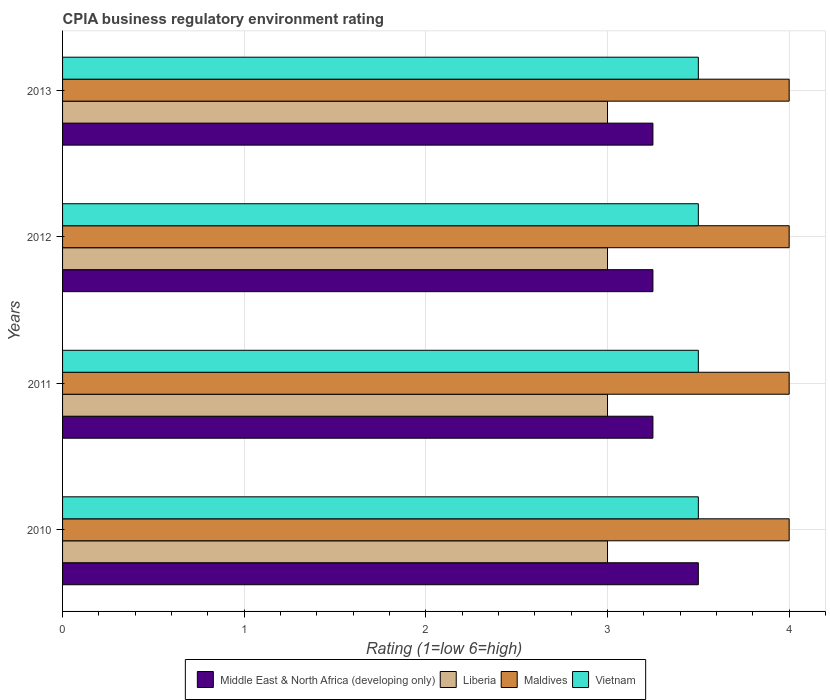How many different coloured bars are there?
Give a very brief answer. 4. Are the number of bars per tick equal to the number of legend labels?
Offer a very short reply. Yes. What is the label of the 4th group of bars from the top?
Offer a very short reply. 2010. What is the CPIA rating in Middle East & North Africa (developing only) in 2010?
Keep it short and to the point. 3.5. Across all years, what is the maximum CPIA rating in Maldives?
Provide a short and direct response. 4. In which year was the CPIA rating in Liberia maximum?
Offer a terse response. 2010. What is the average CPIA rating in Middle East & North Africa (developing only) per year?
Provide a succinct answer. 3.31. Is it the case that in every year, the sum of the CPIA rating in Middle East & North Africa (developing only) and CPIA rating in Liberia is greater than the sum of CPIA rating in Vietnam and CPIA rating in Maldives?
Give a very brief answer. No. What does the 3rd bar from the top in 2013 represents?
Offer a terse response. Liberia. What does the 2nd bar from the bottom in 2012 represents?
Ensure brevity in your answer.  Liberia. How many bars are there?
Make the answer very short. 16. Are all the bars in the graph horizontal?
Make the answer very short. Yes. How many years are there in the graph?
Your answer should be very brief. 4. What is the difference between two consecutive major ticks on the X-axis?
Your answer should be very brief. 1. Does the graph contain grids?
Offer a very short reply. Yes. Where does the legend appear in the graph?
Your response must be concise. Bottom center. What is the title of the graph?
Keep it short and to the point. CPIA business regulatory environment rating. What is the label or title of the X-axis?
Your answer should be compact. Rating (1=low 6=high). What is the label or title of the Y-axis?
Provide a succinct answer. Years. What is the Rating (1=low 6=high) in Middle East & North Africa (developing only) in 2010?
Keep it short and to the point. 3.5. What is the Rating (1=low 6=high) of Maldives in 2010?
Your answer should be compact. 4. What is the Rating (1=low 6=high) in Vietnam in 2010?
Your answer should be very brief. 3.5. What is the Rating (1=low 6=high) of Liberia in 2011?
Keep it short and to the point. 3. What is the Rating (1=low 6=high) in Maldives in 2012?
Ensure brevity in your answer.  4. What is the Rating (1=low 6=high) in Vietnam in 2012?
Provide a succinct answer. 3.5. What is the Rating (1=low 6=high) of Middle East & North Africa (developing only) in 2013?
Keep it short and to the point. 3.25. What is the Rating (1=low 6=high) of Vietnam in 2013?
Your answer should be compact. 3.5. Across all years, what is the maximum Rating (1=low 6=high) in Middle East & North Africa (developing only)?
Make the answer very short. 3.5. Across all years, what is the maximum Rating (1=low 6=high) in Maldives?
Give a very brief answer. 4. Across all years, what is the maximum Rating (1=low 6=high) of Vietnam?
Provide a short and direct response. 3.5. Across all years, what is the minimum Rating (1=low 6=high) in Middle East & North Africa (developing only)?
Your answer should be very brief. 3.25. Across all years, what is the minimum Rating (1=low 6=high) of Liberia?
Offer a very short reply. 3. Across all years, what is the minimum Rating (1=low 6=high) in Vietnam?
Your response must be concise. 3.5. What is the total Rating (1=low 6=high) of Middle East & North Africa (developing only) in the graph?
Your answer should be compact. 13.25. What is the total Rating (1=low 6=high) of Liberia in the graph?
Ensure brevity in your answer.  12. What is the total Rating (1=low 6=high) of Maldives in the graph?
Provide a short and direct response. 16. What is the total Rating (1=low 6=high) in Vietnam in the graph?
Your answer should be very brief. 14. What is the difference between the Rating (1=low 6=high) in Middle East & North Africa (developing only) in 2010 and that in 2011?
Your answer should be compact. 0.25. What is the difference between the Rating (1=low 6=high) of Liberia in 2010 and that in 2011?
Provide a succinct answer. 0. What is the difference between the Rating (1=low 6=high) in Vietnam in 2010 and that in 2011?
Give a very brief answer. 0. What is the difference between the Rating (1=low 6=high) of Maldives in 2010 and that in 2012?
Keep it short and to the point. 0. What is the difference between the Rating (1=low 6=high) in Middle East & North Africa (developing only) in 2010 and that in 2013?
Ensure brevity in your answer.  0.25. What is the difference between the Rating (1=low 6=high) of Liberia in 2010 and that in 2013?
Offer a terse response. 0. What is the difference between the Rating (1=low 6=high) in Maldives in 2010 and that in 2013?
Provide a short and direct response. 0. What is the difference between the Rating (1=low 6=high) of Vietnam in 2010 and that in 2013?
Offer a terse response. 0. What is the difference between the Rating (1=low 6=high) in Middle East & North Africa (developing only) in 2011 and that in 2012?
Your answer should be compact. 0. What is the difference between the Rating (1=low 6=high) of Liberia in 2011 and that in 2012?
Your answer should be compact. 0. What is the difference between the Rating (1=low 6=high) in Maldives in 2011 and that in 2012?
Your response must be concise. 0. What is the difference between the Rating (1=low 6=high) in Vietnam in 2011 and that in 2012?
Make the answer very short. 0. What is the difference between the Rating (1=low 6=high) in Middle East & North Africa (developing only) in 2011 and that in 2013?
Your answer should be very brief. 0. What is the difference between the Rating (1=low 6=high) of Maldives in 2011 and that in 2013?
Offer a very short reply. 0. What is the difference between the Rating (1=low 6=high) of Liberia in 2012 and that in 2013?
Ensure brevity in your answer.  0. What is the difference between the Rating (1=low 6=high) of Maldives in 2012 and that in 2013?
Give a very brief answer. 0. What is the difference between the Rating (1=low 6=high) in Middle East & North Africa (developing only) in 2010 and the Rating (1=low 6=high) in Vietnam in 2011?
Provide a short and direct response. 0. What is the difference between the Rating (1=low 6=high) in Maldives in 2010 and the Rating (1=low 6=high) in Vietnam in 2011?
Offer a very short reply. 0.5. What is the difference between the Rating (1=low 6=high) in Middle East & North Africa (developing only) in 2010 and the Rating (1=low 6=high) in Maldives in 2012?
Your response must be concise. -0.5. What is the difference between the Rating (1=low 6=high) in Middle East & North Africa (developing only) in 2010 and the Rating (1=low 6=high) in Vietnam in 2012?
Give a very brief answer. 0. What is the difference between the Rating (1=low 6=high) in Maldives in 2010 and the Rating (1=low 6=high) in Vietnam in 2012?
Give a very brief answer. 0.5. What is the difference between the Rating (1=low 6=high) of Middle East & North Africa (developing only) in 2010 and the Rating (1=low 6=high) of Maldives in 2013?
Your response must be concise. -0.5. What is the difference between the Rating (1=low 6=high) in Middle East & North Africa (developing only) in 2011 and the Rating (1=low 6=high) in Maldives in 2012?
Your response must be concise. -0.75. What is the difference between the Rating (1=low 6=high) of Middle East & North Africa (developing only) in 2011 and the Rating (1=low 6=high) of Vietnam in 2012?
Your response must be concise. -0.25. What is the difference between the Rating (1=low 6=high) of Maldives in 2011 and the Rating (1=low 6=high) of Vietnam in 2012?
Your response must be concise. 0.5. What is the difference between the Rating (1=low 6=high) of Middle East & North Africa (developing only) in 2011 and the Rating (1=low 6=high) of Maldives in 2013?
Provide a succinct answer. -0.75. What is the difference between the Rating (1=low 6=high) of Middle East & North Africa (developing only) in 2011 and the Rating (1=low 6=high) of Vietnam in 2013?
Provide a succinct answer. -0.25. What is the difference between the Rating (1=low 6=high) of Liberia in 2011 and the Rating (1=low 6=high) of Maldives in 2013?
Ensure brevity in your answer.  -1. What is the difference between the Rating (1=low 6=high) in Middle East & North Africa (developing only) in 2012 and the Rating (1=low 6=high) in Maldives in 2013?
Give a very brief answer. -0.75. What is the difference between the Rating (1=low 6=high) in Maldives in 2012 and the Rating (1=low 6=high) in Vietnam in 2013?
Offer a terse response. 0.5. What is the average Rating (1=low 6=high) in Middle East & North Africa (developing only) per year?
Provide a short and direct response. 3.31. What is the average Rating (1=low 6=high) in Liberia per year?
Your answer should be compact. 3. What is the average Rating (1=low 6=high) of Maldives per year?
Your response must be concise. 4. What is the average Rating (1=low 6=high) of Vietnam per year?
Offer a very short reply. 3.5. In the year 2010, what is the difference between the Rating (1=low 6=high) of Liberia and Rating (1=low 6=high) of Maldives?
Your response must be concise. -1. In the year 2011, what is the difference between the Rating (1=low 6=high) of Middle East & North Africa (developing only) and Rating (1=low 6=high) of Maldives?
Your response must be concise. -0.75. In the year 2011, what is the difference between the Rating (1=low 6=high) of Liberia and Rating (1=low 6=high) of Maldives?
Keep it short and to the point. -1. In the year 2012, what is the difference between the Rating (1=low 6=high) of Middle East & North Africa (developing only) and Rating (1=low 6=high) of Liberia?
Give a very brief answer. 0.25. In the year 2012, what is the difference between the Rating (1=low 6=high) of Middle East & North Africa (developing only) and Rating (1=low 6=high) of Maldives?
Make the answer very short. -0.75. In the year 2012, what is the difference between the Rating (1=low 6=high) in Liberia and Rating (1=low 6=high) in Maldives?
Offer a terse response. -1. In the year 2013, what is the difference between the Rating (1=low 6=high) in Middle East & North Africa (developing only) and Rating (1=low 6=high) in Maldives?
Your answer should be compact. -0.75. In the year 2013, what is the difference between the Rating (1=low 6=high) of Liberia and Rating (1=low 6=high) of Vietnam?
Offer a very short reply. -0.5. What is the ratio of the Rating (1=low 6=high) in Middle East & North Africa (developing only) in 2010 to that in 2011?
Give a very brief answer. 1.08. What is the ratio of the Rating (1=low 6=high) of Maldives in 2010 to that in 2011?
Provide a short and direct response. 1. What is the ratio of the Rating (1=low 6=high) in Vietnam in 2010 to that in 2011?
Offer a terse response. 1. What is the ratio of the Rating (1=low 6=high) of Middle East & North Africa (developing only) in 2010 to that in 2012?
Offer a terse response. 1.08. What is the ratio of the Rating (1=low 6=high) in Liberia in 2010 to that in 2012?
Offer a very short reply. 1. What is the ratio of the Rating (1=low 6=high) of Liberia in 2010 to that in 2013?
Keep it short and to the point. 1. What is the ratio of the Rating (1=low 6=high) of Vietnam in 2010 to that in 2013?
Provide a short and direct response. 1. What is the ratio of the Rating (1=low 6=high) of Middle East & North Africa (developing only) in 2011 to that in 2012?
Give a very brief answer. 1. What is the ratio of the Rating (1=low 6=high) of Vietnam in 2011 to that in 2012?
Make the answer very short. 1. What is the ratio of the Rating (1=low 6=high) of Middle East & North Africa (developing only) in 2011 to that in 2013?
Offer a terse response. 1. What is the ratio of the Rating (1=low 6=high) of Liberia in 2011 to that in 2013?
Offer a very short reply. 1. What is the ratio of the Rating (1=low 6=high) of Maldives in 2011 to that in 2013?
Your answer should be very brief. 1. What is the ratio of the Rating (1=low 6=high) in Vietnam in 2011 to that in 2013?
Your response must be concise. 1. What is the ratio of the Rating (1=low 6=high) of Middle East & North Africa (developing only) in 2012 to that in 2013?
Give a very brief answer. 1. What is the ratio of the Rating (1=low 6=high) of Liberia in 2012 to that in 2013?
Your answer should be compact. 1. What is the ratio of the Rating (1=low 6=high) of Maldives in 2012 to that in 2013?
Offer a terse response. 1. What is the ratio of the Rating (1=low 6=high) of Vietnam in 2012 to that in 2013?
Your answer should be compact. 1. What is the difference between the highest and the second highest Rating (1=low 6=high) in Middle East & North Africa (developing only)?
Ensure brevity in your answer.  0.25. What is the difference between the highest and the lowest Rating (1=low 6=high) of Liberia?
Your response must be concise. 0. What is the difference between the highest and the lowest Rating (1=low 6=high) in Vietnam?
Keep it short and to the point. 0. 